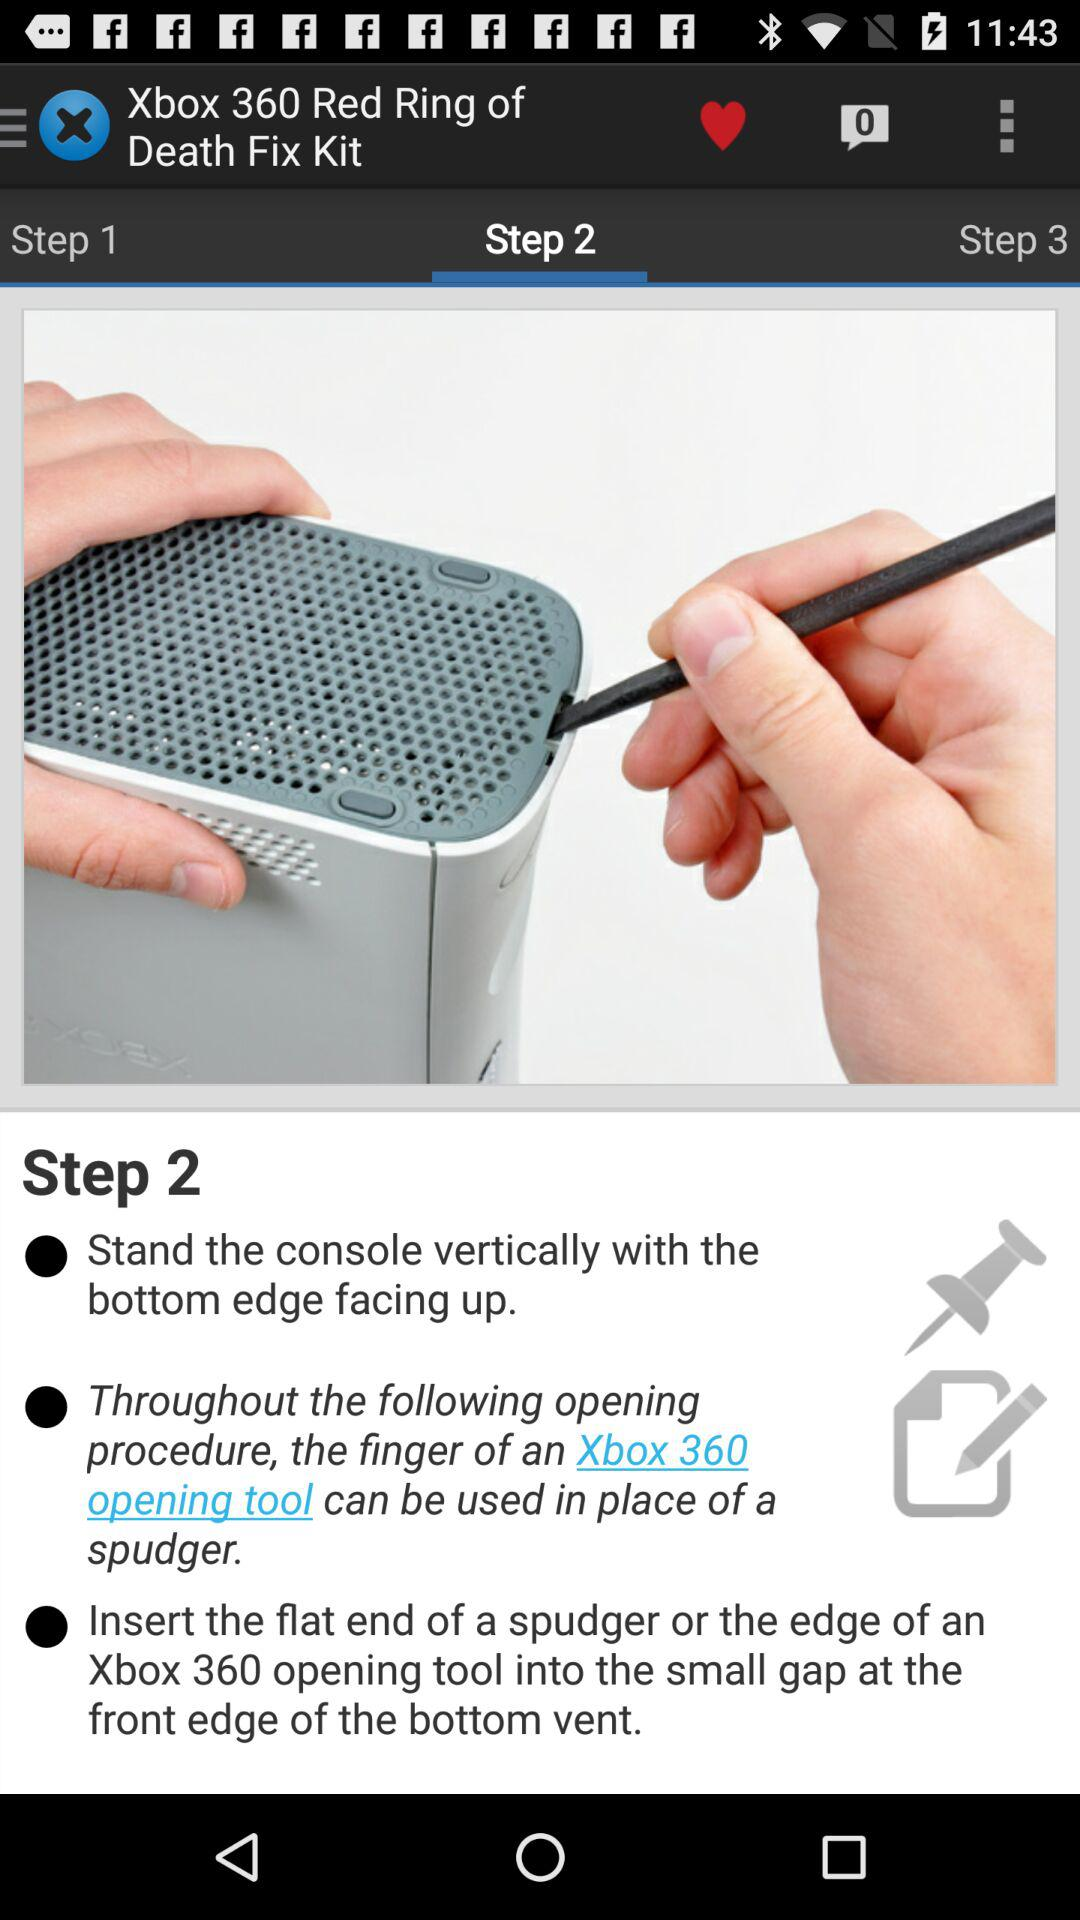How many steps are there in the repair process?
Answer the question using a single word or phrase. 3 